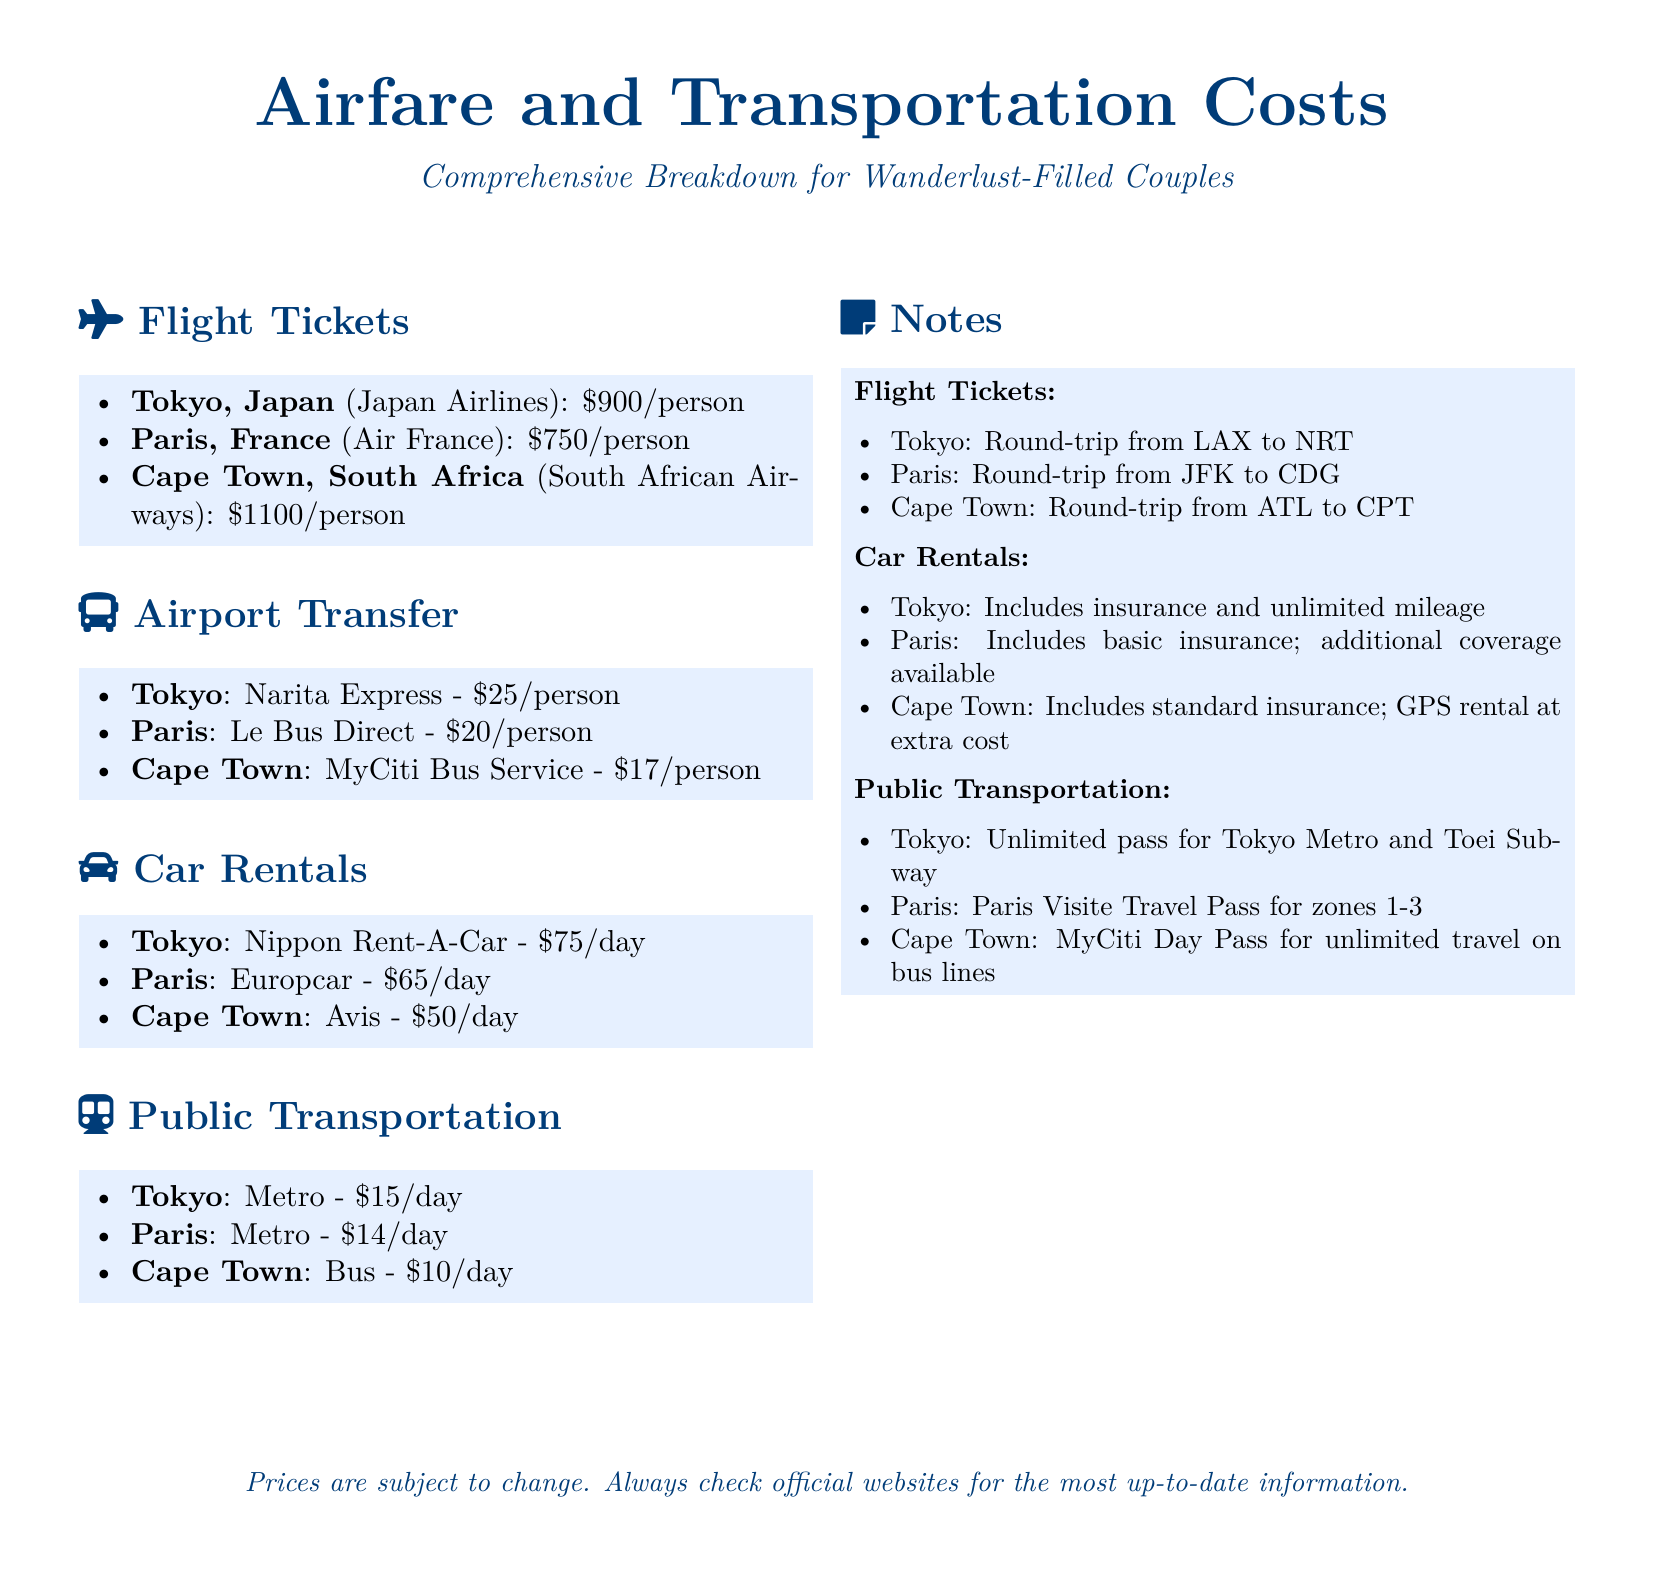What is the airfare to Tokyo? The airfare to Tokyo is provided in the flight tickets section, which states it is $900 per person.
Answer: $900/person What is the airport transfer cost in Paris? The airport transfer cost in Paris is found in the airport transfer section, which lists it as $20 per person.
Answer: $20/person How much does it cost to rent a car in Cape Town? The car rental section indicates that the cost to rent a car in Cape Town is $50 per day.
Answer: $50/day What is the daily public transportation cost in Tokyo? The daily public transportation cost in Tokyo is mentioned as $15 in the public transportation section.
Answer: $15/day Which airline operates flights to Cape Town? The flight tickets section lists South African Airways as the airline that operates flights to Cape Town.
Answer: South African Airways Which service provides airport transfer in Tokyo? The airport transfer section specifies that the Narita Express provides airport transfer in Tokyo.
Answer: Narita Express What is included in the car rental for Paris? The notes indicate that the Paris car rental includes basic insurance and additional coverage available.
Answer: Basic insurance What type of transportation pass is available in Paris? The public transportation notes mention that the Paris Visite Travel Pass is available for zones 1-3.
Answer: Paris Visite Travel Pass What is the round-trip flight path for Tokyo? The notes about flight tickets mention that the round-trip flight path for Tokyo is from LAX to NRT.
Answer: LAX to NRT 